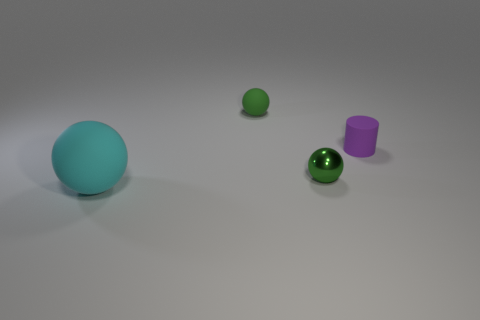Add 2 green matte cylinders. How many objects exist? 6 Subtract all cylinders. How many objects are left? 3 Add 3 tiny purple metal things. How many tiny purple metal things exist? 3 Subtract 0 brown spheres. How many objects are left? 4 Subtract all small yellow shiny cylinders. Subtract all small green matte balls. How many objects are left? 3 Add 2 large matte balls. How many large matte balls are left? 3 